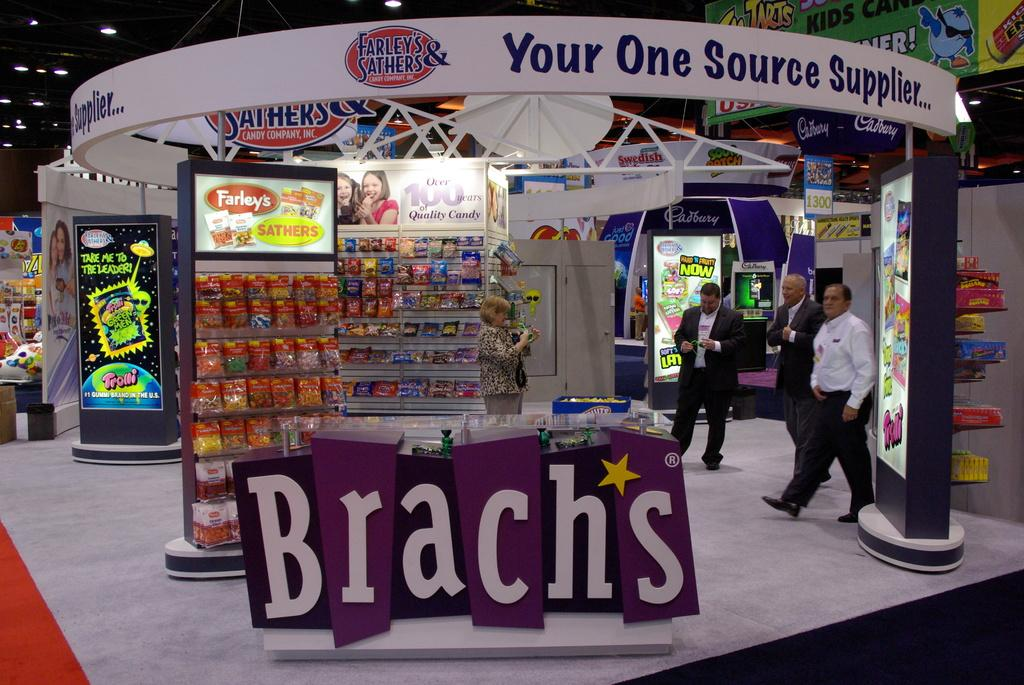<image>
Provide a brief description of the given image. A Brach's candy display has a colorful purple sign. 